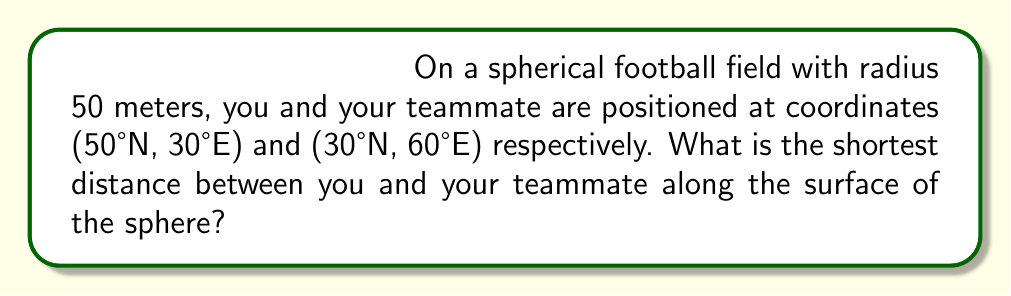Can you answer this question? To solve this problem, we'll use the great circle distance formula, which gives the shortest path between two points on a sphere. The steps are as follows:

1) Convert the coordinates to radians:
   $\phi_1 = 50° \cdot \frac{\pi}{180} = \frac{5\pi}{18}$
   $\lambda_1 = 30° \cdot \frac{\pi}{180} = \frac{\pi}{6}$
   $\phi_2 = 30° \cdot \frac{\pi}{180} = \frac{\pi}{6}$
   $\lambda_2 = 60° \cdot \frac{\pi}{180} = \frac{\pi}{3}$

2) Apply the great circle distance formula:
   $$\Delta\sigma = \arccos(\sin\phi_1 \sin\phi_2 + \cos\phi_1 \cos\phi_2 \cos(\Delta\lambda))$$
   where $\Delta\lambda = |\lambda_1 - \lambda_2|$

3) Calculate $\Delta\lambda$:
   $\Delta\lambda = |\frac{\pi}{6} - \frac{\pi}{3}| = \frac{\pi}{6}$

4) Substitute into the formula:
   $$\Delta\sigma = \arccos(\sin(\frac{5\pi}{18}) \sin(\frac{\pi}{6}) + \cos(\frac{5\pi}{18}) \cos(\frac{\pi}{6}) \cos(\frac{\pi}{6}))$$

5) Evaluate (using a calculator):
   $\Delta\sigma \approx 0.4874$ radians

6) Convert to distance on the sphere:
   Distance = $R \cdot \Delta\sigma$, where $R$ is the radius of the sphere
   Distance = $50 \cdot 0.4874 \approx 24.37$ meters

Therefore, the shortest distance between you and your teammate along the surface of the spherical field is approximately 24.37 meters.
Answer: 24.37 meters 